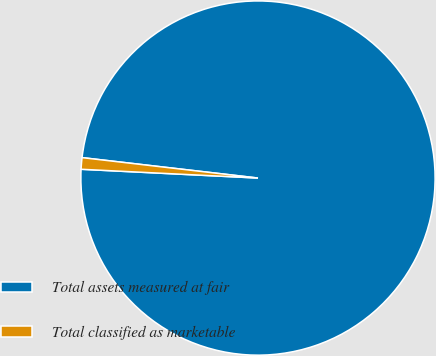Convert chart to OTSL. <chart><loc_0><loc_0><loc_500><loc_500><pie_chart><fcel>Total assets measured at fair<fcel>Total classified as marketable<nl><fcel>98.95%<fcel>1.05%<nl></chart> 